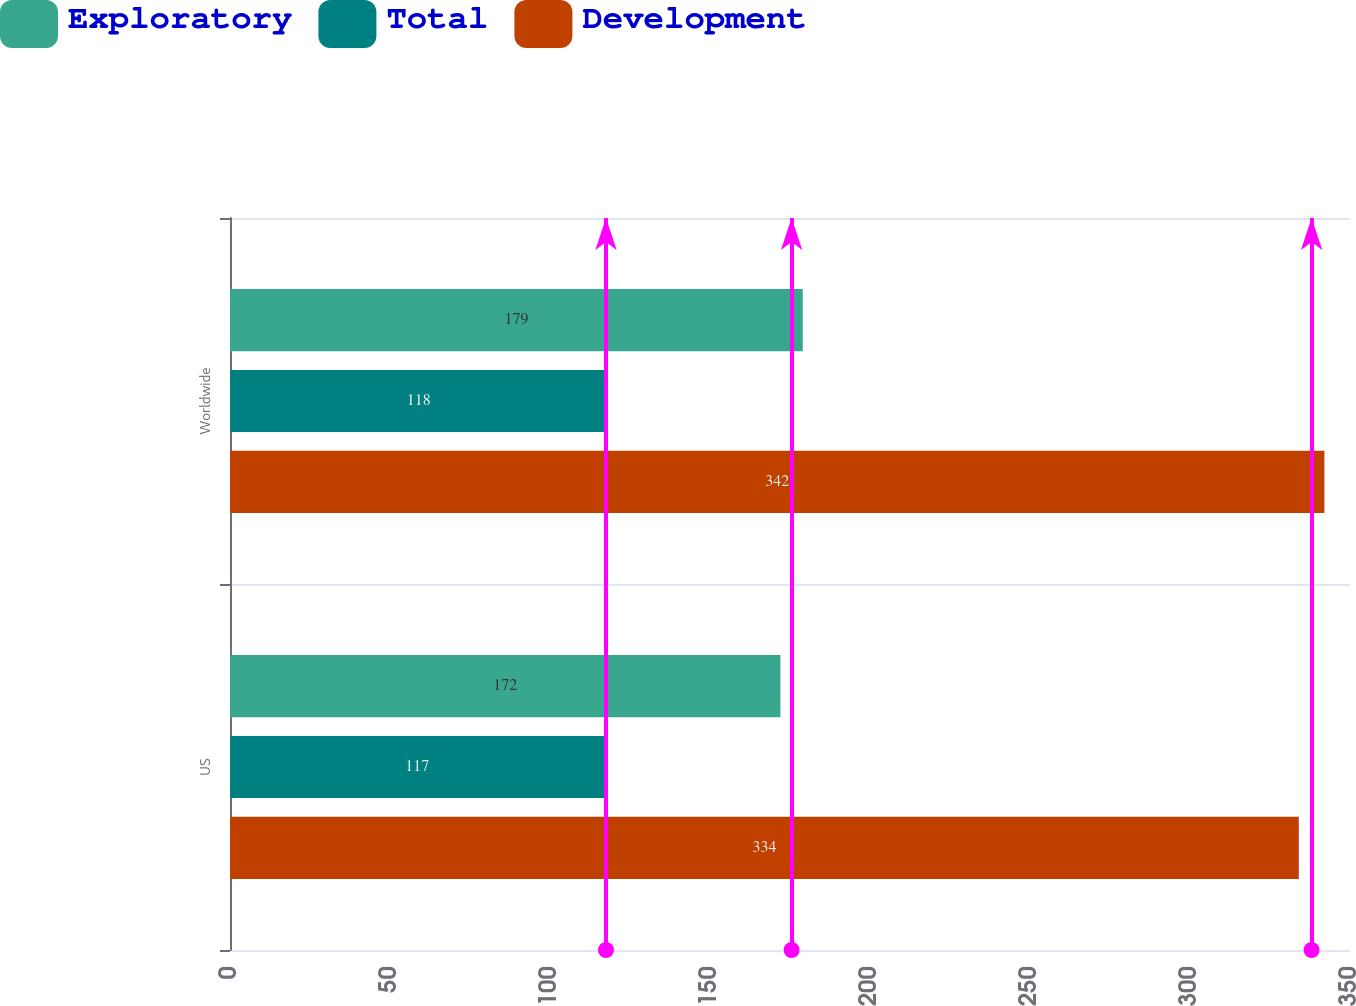Convert chart. <chart><loc_0><loc_0><loc_500><loc_500><stacked_bar_chart><ecel><fcel>US<fcel>Worldwide<nl><fcel>Exploratory<fcel>172<fcel>179<nl><fcel>Total<fcel>117<fcel>118<nl><fcel>Development<fcel>334<fcel>342<nl></chart> 